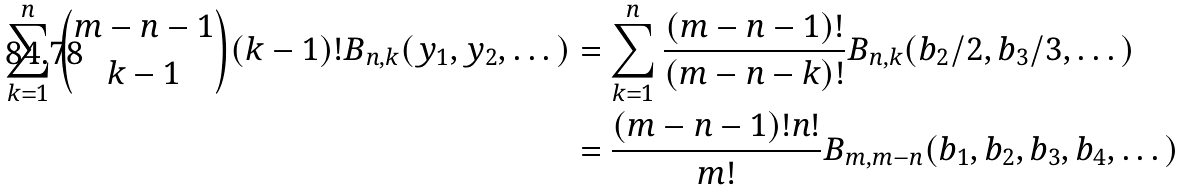<formula> <loc_0><loc_0><loc_500><loc_500>\sum _ { k = 1 } ^ { n } \binom { m - n - 1 } { k - 1 } ( k - 1 ) ! B _ { n , k } ( y _ { 1 } , y _ { 2 } , \dots ) & = \sum _ { k = 1 } ^ { n } \frac { ( m - n - 1 ) ! } { ( m - n - k ) ! } B _ { n , k } ( b _ { 2 } / 2 , b _ { 3 } / 3 , \dots ) \\ & = \frac { ( m - n - 1 ) ! n ! } { m ! } B _ { m , m - n } ( b _ { 1 } , b _ { 2 } , b _ { 3 } , b _ { 4 } , \dots )</formula> 